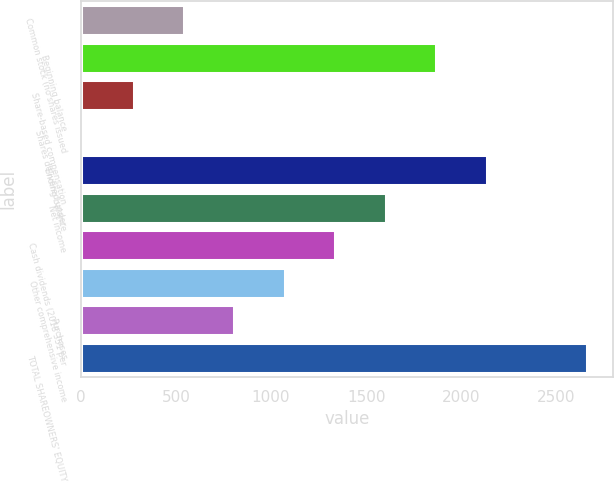Convert chart to OTSL. <chart><loc_0><loc_0><loc_500><loc_500><bar_chart><fcel>Common stock (no shares issued<fcel>Beginning balance<fcel>Share-based compensation<fcel>Shares delivered under<fcel>Ending balance<fcel>Net income<fcel>Cash dividends (2018 351 per<fcel>Other comprehensive income<fcel>Purchases<fcel>TOTAL SHAREOWNERS' EQUITY<nl><fcel>542.64<fcel>1868.24<fcel>277.52<fcel>12.4<fcel>2133.36<fcel>1603.12<fcel>1338<fcel>1072.88<fcel>807.76<fcel>2663.6<nl></chart> 